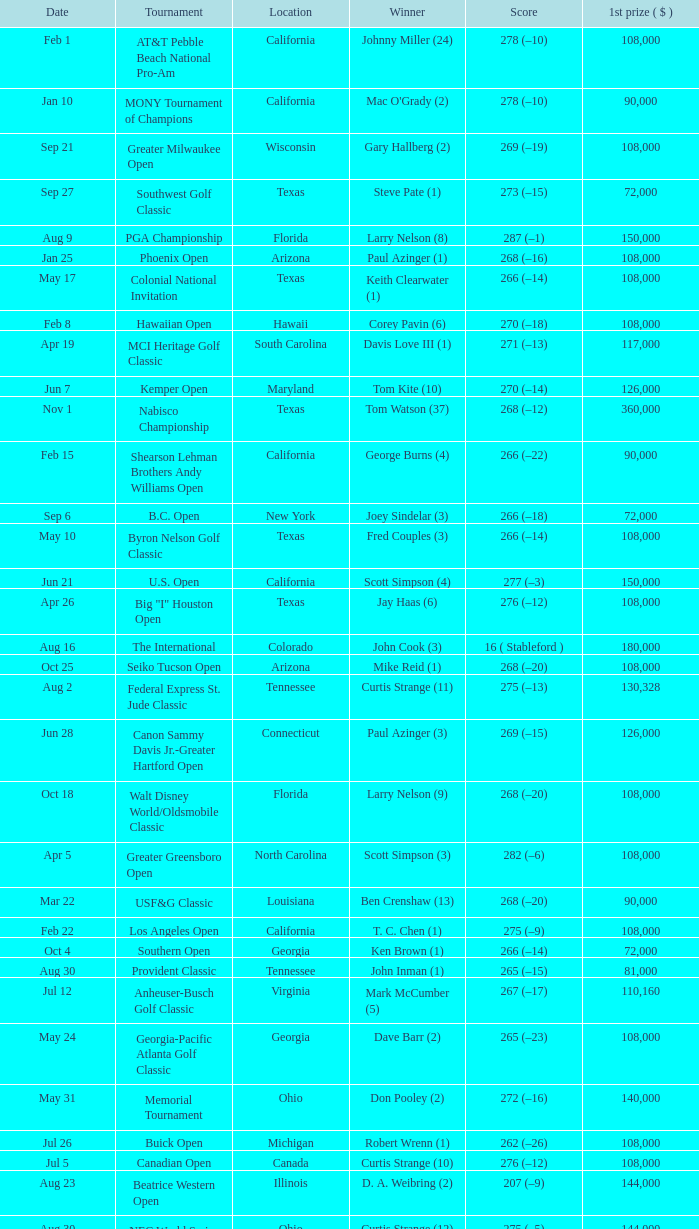What is the score from the winner Keith Clearwater (1)? 266 (–14). 